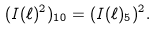Convert formula to latex. <formula><loc_0><loc_0><loc_500><loc_500>( I ( \ell ) ^ { 2 } ) _ { 1 0 } = ( I ( \ell ) _ { 5 } ) ^ { 2 } .</formula> 